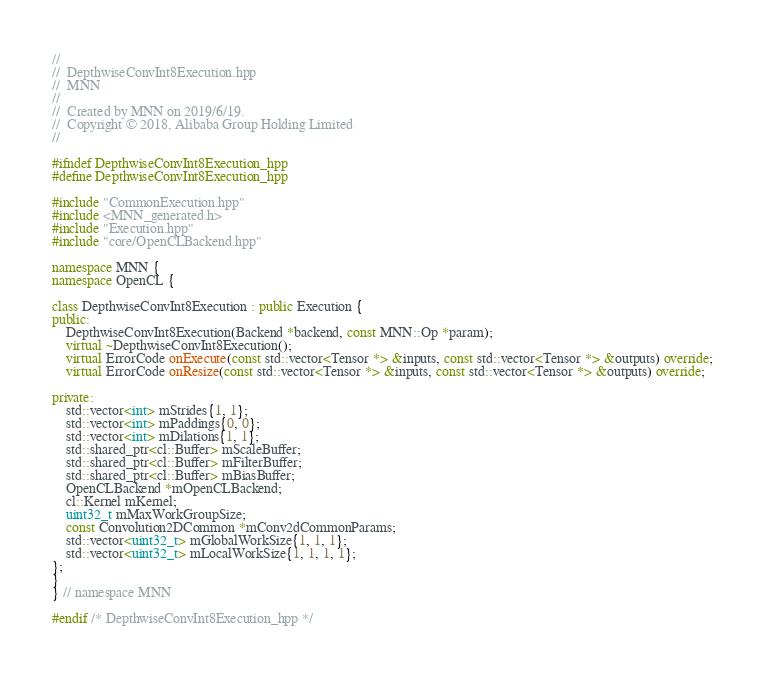<code> <loc_0><loc_0><loc_500><loc_500><_C++_>//
//  DepthwiseConvInt8Execution.hpp
//  MNN
//
//  Created by MNN on 2019/6/19.
//  Copyright © 2018, Alibaba Group Holding Limited
//

#ifndef DepthwiseConvInt8Execution_hpp
#define DepthwiseConvInt8Execution_hpp

#include "CommonExecution.hpp"
#include <MNN_generated.h>
#include "Execution.hpp"
#include "core/OpenCLBackend.hpp"

namespace MNN {
namespace OpenCL {

class DepthwiseConvInt8Execution : public Execution {
public:
    DepthwiseConvInt8Execution(Backend *backend, const MNN::Op *param);
    virtual ~DepthwiseConvInt8Execution();
    virtual ErrorCode onExecute(const std::vector<Tensor *> &inputs, const std::vector<Tensor *> &outputs) override;
    virtual ErrorCode onResize(const std::vector<Tensor *> &inputs, const std::vector<Tensor *> &outputs) override;

private:
    std::vector<int> mStrides{1, 1};
    std::vector<int> mPaddings{0, 0};
    std::vector<int> mDilations{1, 1};
    std::shared_ptr<cl::Buffer> mScaleBuffer;
    std::shared_ptr<cl::Buffer> mFilterBuffer;
    std::shared_ptr<cl::Buffer> mBiasBuffer;
    OpenCLBackend *mOpenCLBackend;
    cl::Kernel mKernel;
    uint32_t mMaxWorkGroupSize;
    const Convolution2DCommon *mConv2dCommonParams;
    std::vector<uint32_t> mGlobalWorkSize{1, 1, 1};
    std::vector<uint32_t> mLocalWorkSize{1, 1, 1, 1};
};
}
} // namespace MNN

#endif /* DepthwiseConvInt8Execution_hpp */
</code> 